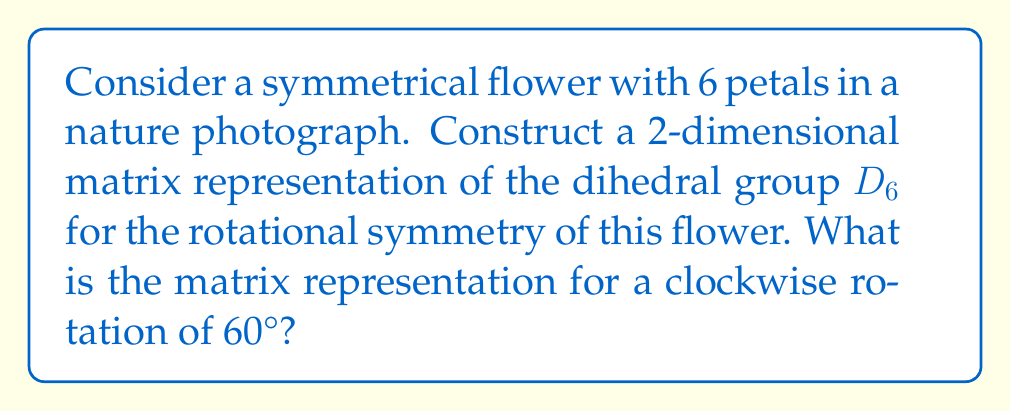Can you solve this math problem? Let's approach this step-by-step:

1) The dihedral group $D_6$ represents the symmetries of a regular hexagon, which matches our 6-petaled flower.

2) For a 2-dimensional representation, we'll use 2x2 matrices to represent the transformations.

3) The rotational symmetry of 60° clockwise can be represented using a rotation matrix.

4) The general form of a 2D rotation matrix for an angle $\theta$ is:

   $$\begin{pmatrix} \cos\theta & -\sin\theta \\ \sin\theta & \cos\theta \end{pmatrix}$$

5) In our case, $\theta = 60° = \frac{\pi}{3}$ radians.

6) We know that:
   $\cos(\frac{\pi}{3}) = \frac{1}{2}$
   $\sin(\frac{\pi}{3}) = \frac{\sqrt{3}}{2}$

7) Substituting these values into our rotation matrix:

   $$\begin{pmatrix} \frac{1}{2} & -\frac{\sqrt{3}}{2} \\ \frac{\sqrt{3}}{2} & \frac{1}{2} \end{pmatrix}$$

This matrix represents a clockwise rotation of 60° for our flower in the photograph, capturing one of the symmetries in the dihedral group $D_6$.
Answer: $$\begin{pmatrix} \frac{1}{2} & -\frac{\sqrt{3}}{2} \\ \frac{\sqrt{3}}{2} & \frac{1}{2} \end{pmatrix}$$ 